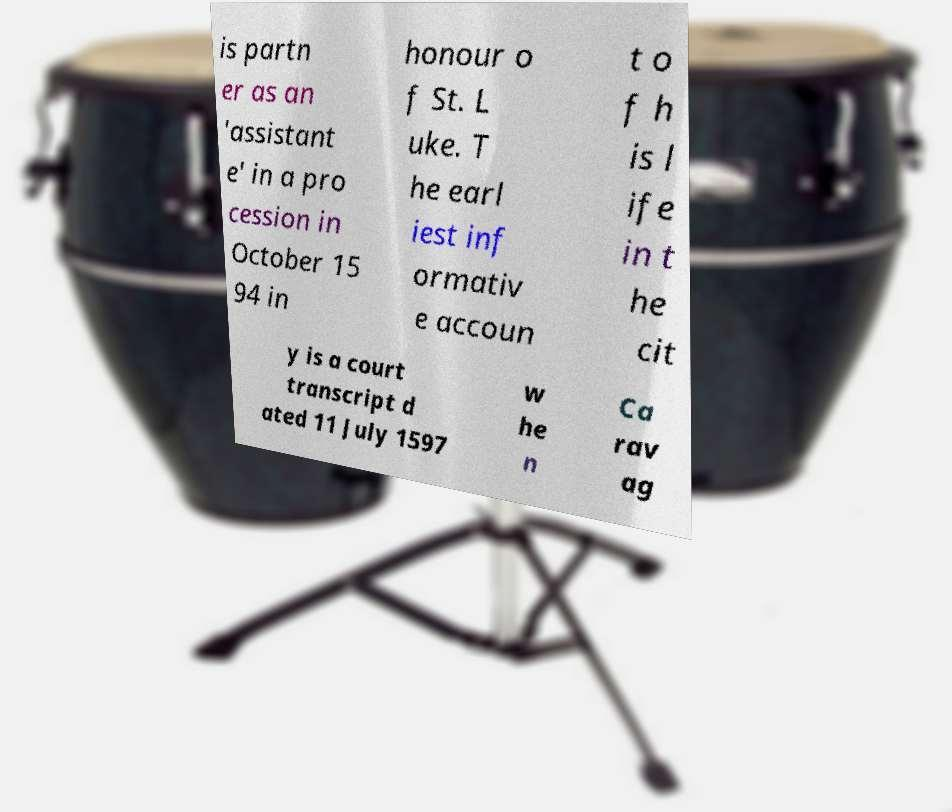Please identify and transcribe the text found in this image. is partn er as an 'assistant e' in a pro cession in October 15 94 in honour o f St. L uke. T he earl iest inf ormativ e accoun t o f h is l ife in t he cit y is a court transcript d ated 11 July 1597 w he n Ca rav ag 